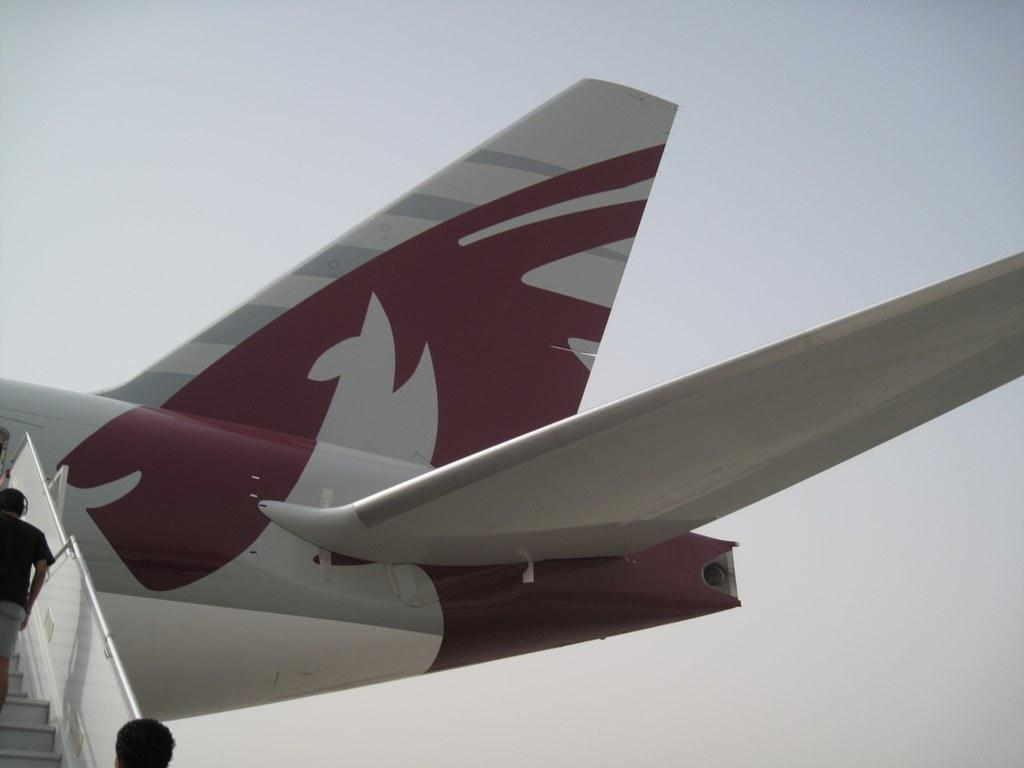What is the main subject of the image? The main subject of the image is a white-colored flight. What can be seen beside the flight? There are boarding steps beside the flight. Are there any people present in the image? Yes, two people are present near the boarding steps. What is the color of the sky in the image? The sky is blue in color. What is the rate of peace in the image? The concept of peace is not present in the image, as it features a flight and boarding steps. Is there a battle taking place in the image? No, there is no battle depicted in the image; it shows a flight and boarding steps. 